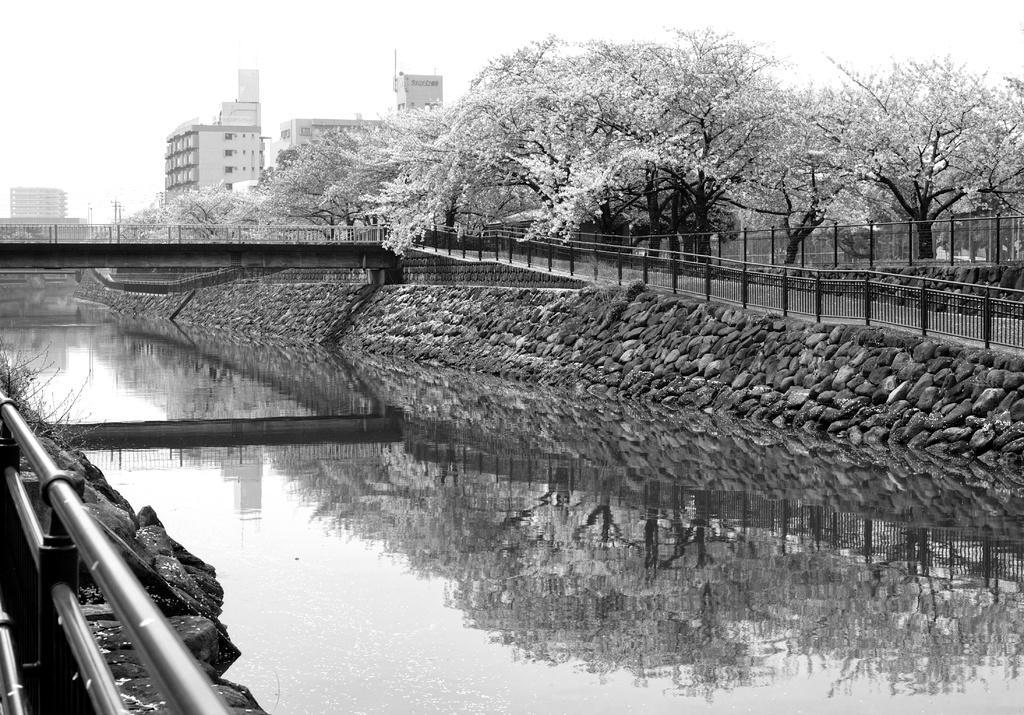Describe this image in one or two sentences. This picture is a black and white image. In this image we can see one canal, one bridge, one path, few fences, some rocks, some trees, some buildings in the background, few objects on the ground, some poles, some grass on the ground and at the top there is the sky. 